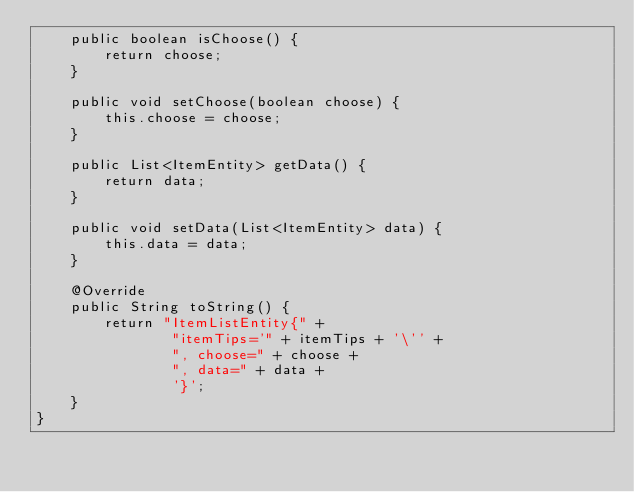<code> <loc_0><loc_0><loc_500><loc_500><_Java_>    public boolean isChoose() {
        return choose;
    }

    public void setChoose(boolean choose) {
        this.choose = choose;
    }

    public List<ItemEntity> getData() {
        return data;
    }

    public void setData(List<ItemEntity> data) {
        this.data = data;
    }

    @Override
    public String toString() {
        return "ItemListEntity{" +
                "itemTips='" + itemTips + '\'' +
                ", choose=" + choose +
                ", data=" + data +
                '}';
    }
}
</code> 